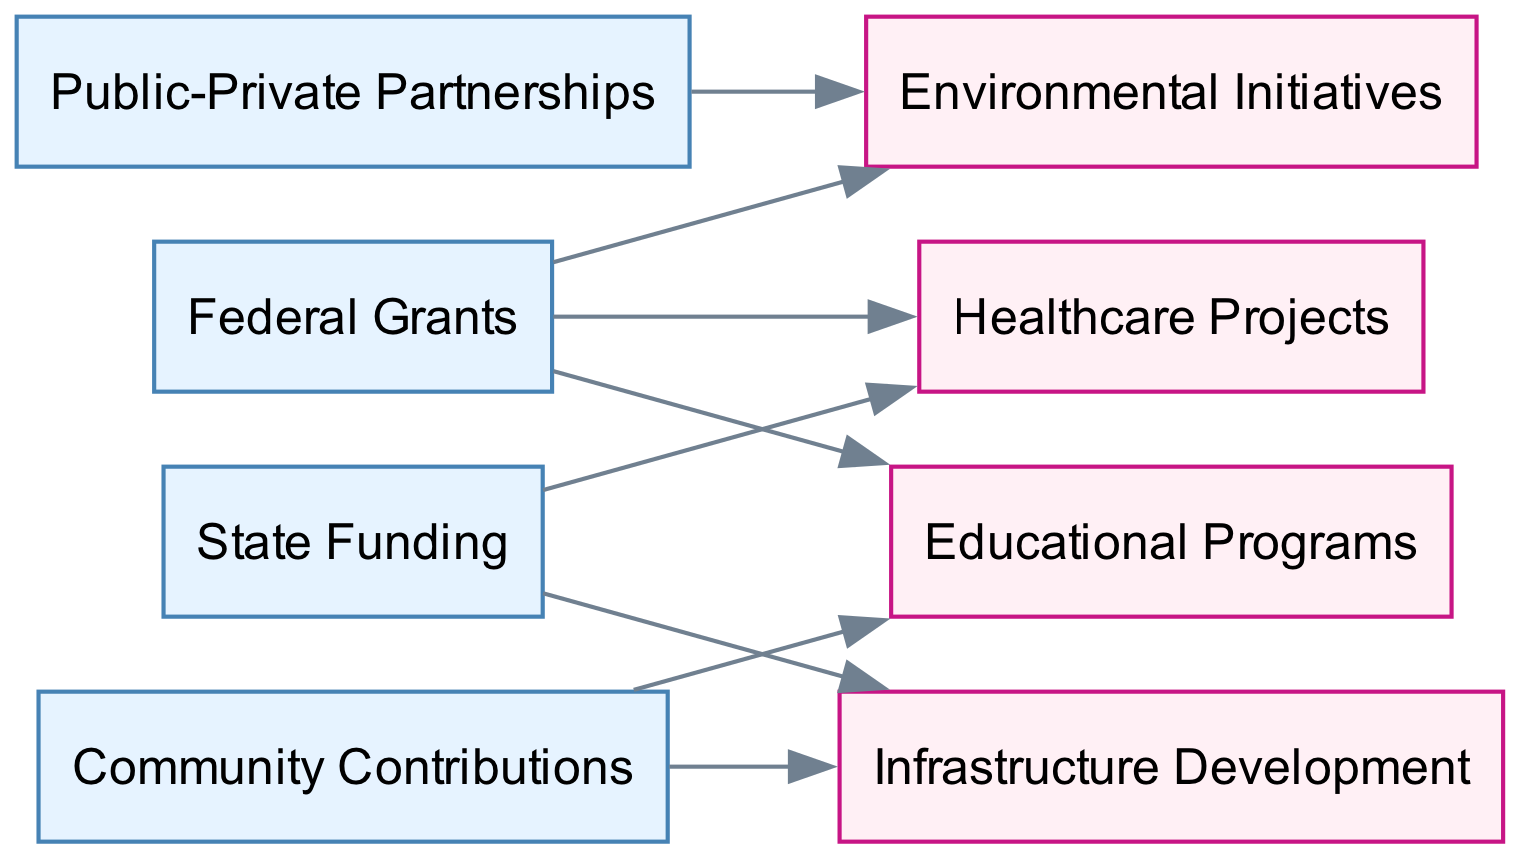What are the sources of funding in the diagram? Inspecting the nodes labeled in the diagram, the sources of funding include "Federal Grants," "State Funding," "Public-Private Partnerships," and "Community Contributions." These represent the nodes numbered 1, 2, 3, and 4 respectively.
Answer: Federal Grants, State Funding, Public-Private Partnerships, Community Contributions How many initiatives are funded by Federal Grants? Observing the edges originating from the node labeled "Federal Grants," we see connections to "Environmental Initiatives," "Healthcare Projects," and "Educational Programs." This totals three initiatives funded by Federal Grants.
Answer: 3 What types of projects are supported by State Funding? By looking at the edges pointing from the "State Funding" node, we see there are connections to "Healthcare Projects" and "Infrastructure Development." This indicates that State Funding supports these two types of projects.
Answer: Healthcare Projects, Infrastructure Development Which funding source is linked to the most initiatives? Analyzing the edges, it appears that both "Federal Grants" and "Community Contributions" fund three initiatives each (Federal Grants: Environmental Initiatives, Healthcare Projects, Educational Programs; Community Contributions: Educational Programs, Infrastructure Development). Since no other funding source has more than two links, the maximum is three initiatives.
Answer: Federal Grants, Community Contributions Is there a direct funding relationship between Public-Private Partnerships and Education Programs? Checking the edges in the diagram, there is no edge connecting the "Public-Private Partnerships" node to the "Educational Programs" node, thus indicating no direct funding relationship between these two.
Answer: No How many total edges are present in the diagram? Counting the total connections (or edges), there are eight edges connecting various nodes as per the provided data.
Answer: 8 What initiative is funded by Community Contributions? Looking at the edges from the "Community Contributions" node, we find links to "Educational Programs" and "Infrastructure Development." Therefore, both initiatives are funded by Community Contributions.
Answer: Educational Programs, Infrastructure Development Which two funding sources are connected to Healthcare Projects? By reviewing the connections to "Healthcare Projects," we find that both "Federal Grants" and "State Funding" are linked to this initiative. Hence, these are the two funding sources involved.
Answer: Federal Grants, State Funding 